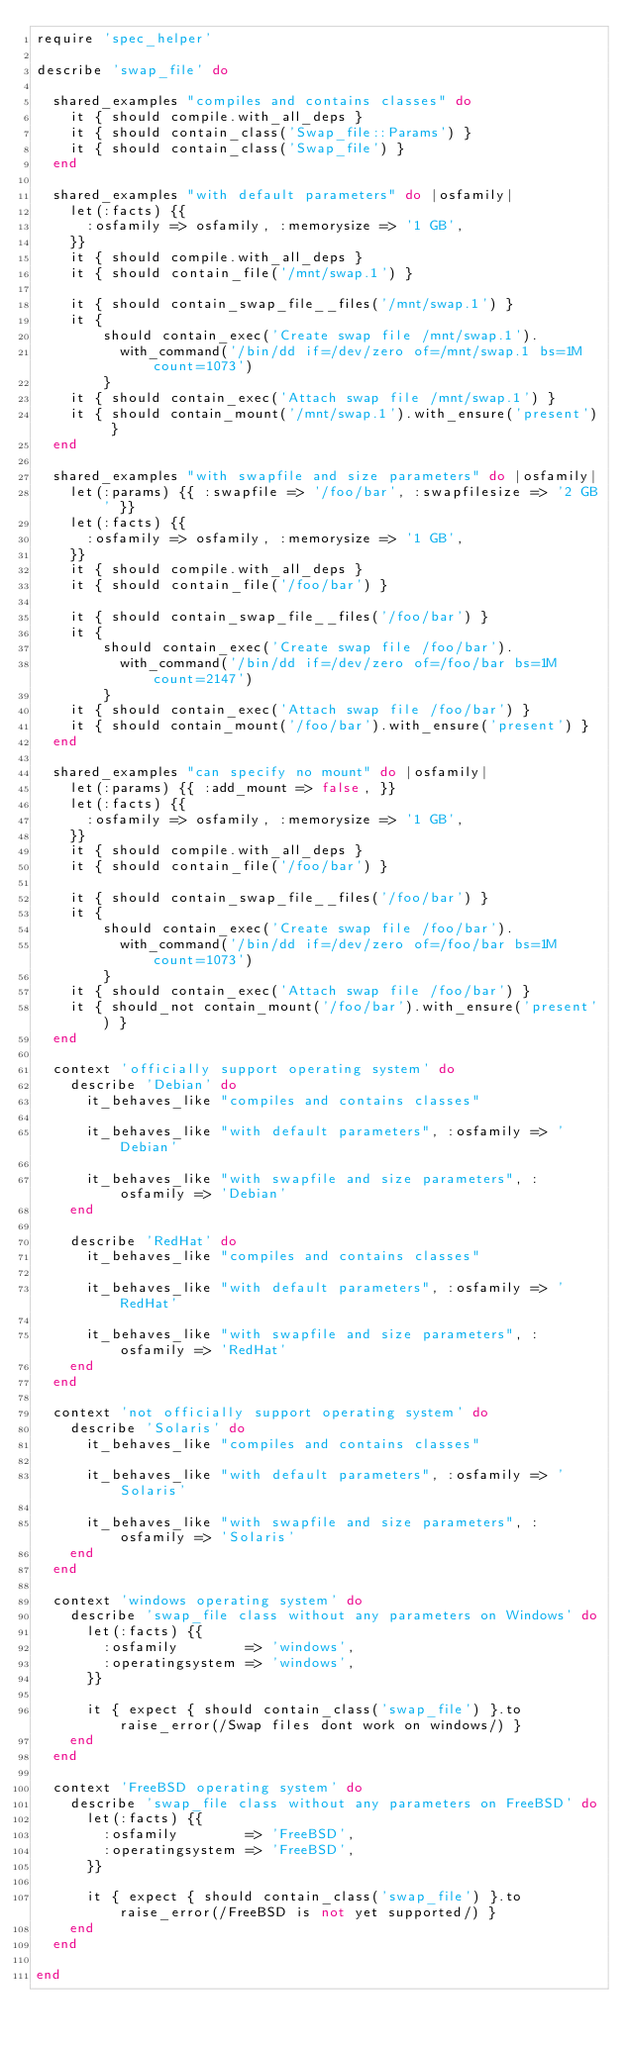<code> <loc_0><loc_0><loc_500><loc_500><_Ruby_>require 'spec_helper'

describe 'swap_file' do

  shared_examples "compiles and contains classes" do
    it { should compile.with_all_deps }
    it { should contain_class('Swap_file::Params') }
    it { should contain_class('Swap_file') }
  end

  shared_examples "with default parameters" do |osfamily|
    let(:facts) {{
      :osfamily => osfamily, :memorysize => '1 GB',
    }}
    it { should compile.with_all_deps }
    it { should contain_file('/mnt/swap.1') }

    it { should contain_swap_file__files('/mnt/swap.1') }
    it {
        should contain_exec('Create swap file /mnt/swap.1').
          with_command('/bin/dd if=/dev/zero of=/mnt/swap.1 bs=1M count=1073')
        }
    it { should contain_exec('Attach swap file /mnt/swap.1') }
    it { should contain_mount('/mnt/swap.1').with_ensure('present') }
  end

  shared_examples "with swapfile and size parameters" do |osfamily|
    let(:params) {{ :swapfile => '/foo/bar', :swapfilesize => '2 GB' }}
    let(:facts) {{
      :osfamily => osfamily, :memorysize => '1 GB',
    }}
    it { should compile.with_all_deps }
    it { should contain_file('/foo/bar') }

    it { should contain_swap_file__files('/foo/bar') }
    it {
        should contain_exec('Create swap file /foo/bar').
          with_command('/bin/dd if=/dev/zero of=/foo/bar bs=1M count=2147')
        }
    it { should contain_exec('Attach swap file /foo/bar') }
    it { should contain_mount('/foo/bar').with_ensure('present') }
  end

  shared_examples "can specify no mount" do |osfamily|
    let(:params) {{ :add_mount => false, }}
    let(:facts) {{
      :osfamily => osfamily, :memorysize => '1 GB',
    }}
    it { should compile.with_all_deps }
    it { should contain_file('/foo/bar') }

    it { should contain_swap_file__files('/foo/bar') }
    it {
        should contain_exec('Create swap file /foo/bar').
          with_command('/bin/dd if=/dev/zero of=/foo/bar bs=1M count=1073')
        }
    it { should contain_exec('Attach swap file /foo/bar') }
    it { should_not contain_mount('/foo/bar').with_ensure('present') }
  end

  context 'officially support operating system' do
    describe 'Debian' do
      it_behaves_like "compiles and contains classes"

      it_behaves_like "with default parameters", :osfamily => 'Debian'

      it_behaves_like "with swapfile and size parameters", :osfamily => 'Debian'
    end

    describe 'RedHat' do
      it_behaves_like "compiles and contains classes"

      it_behaves_like "with default parameters", :osfamily => 'RedHat'

      it_behaves_like "with swapfile and size parameters", :osfamily => 'RedHat'
    end
  end

  context 'not officially support operating system' do
    describe 'Solaris' do
      it_behaves_like "compiles and contains classes"

      it_behaves_like "with default parameters", :osfamily => 'Solaris'

      it_behaves_like "with swapfile and size parameters", :osfamily => 'Solaris'
    end
  end

  context 'windows operating system' do
    describe 'swap_file class without any parameters on Windows' do
      let(:facts) {{
        :osfamily        => 'windows',
        :operatingsystem => 'windows',
      }}

      it { expect { should contain_class('swap_file') }.to raise_error(/Swap files dont work on windows/) }
    end
  end

  context 'FreeBSD operating system' do
    describe 'swap_file class without any parameters on FreeBSD' do
      let(:facts) {{
        :osfamily        => 'FreeBSD',
        :operatingsystem => 'FreeBSD',
      }}

      it { expect { should contain_class('swap_file') }.to raise_error(/FreeBSD is not yet supported/) }
    end
  end

end
</code> 